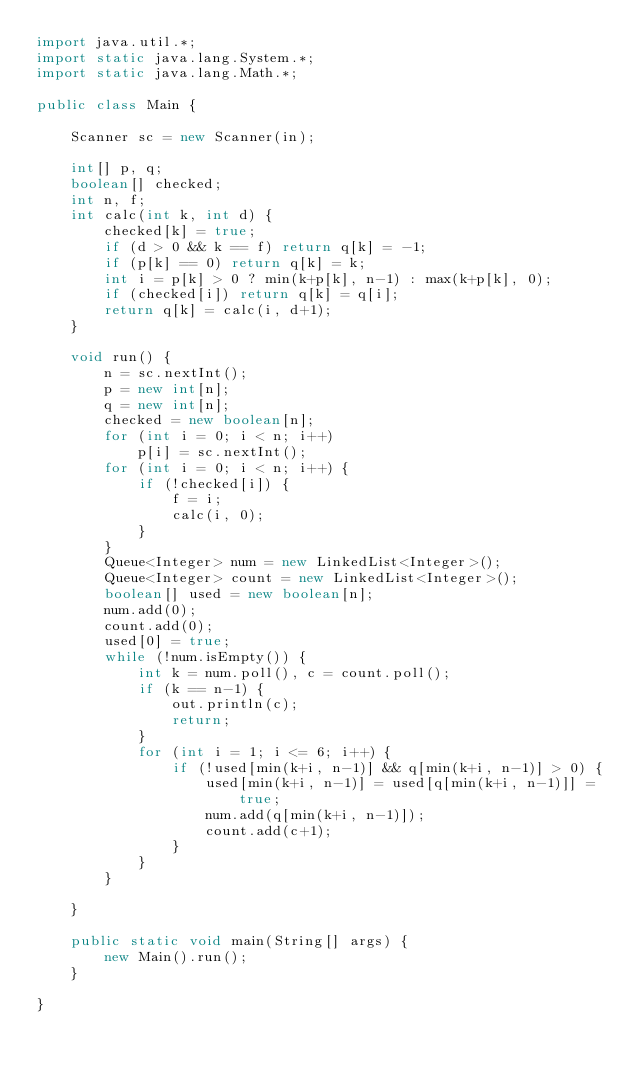Convert code to text. <code><loc_0><loc_0><loc_500><loc_500><_Java_>import java.util.*;
import static java.lang.System.*;
import static java.lang.Math.*;

public class Main {

	Scanner sc = new Scanner(in);
	
	int[] p, q;
	boolean[] checked;
	int n, f;
	int calc(int k, int d) {
		checked[k] = true;
		if (d > 0 && k == f) return q[k] = -1;
		if (p[k] == 0) return q[k] = k;
		int i = p[k] > 0 ? min(k+p[k], n-1) : max(k+p[k], 0);
		if (checked[i]) return q[k] = q[i];
		return q[k] = calc(i, d+1);
	}
	
	void run() {
		n = sc.nextInt();
		p = new int[n];
		q = new int[n];
		checked = new boolean[n];
		for (int i = 0; i < n; i++)
			p[i] = sc.nextInt();
		for (int i = 0; i < n; i++) {
			if (!checked[i]) {
				f = i;
				calc(i, 0);
			}
		}
		Queue<Integer> num = new LinkedList<Integer>();
		Queue<Integer> count = new LinkedList<Integer>();
		boolean[] used = new boolean[n];
		num.add(0);
		count.add(0);
		used[0] = true;
		while (!num.isEmpty()) {
			int k = num.poll(), c = count.poll();
			if (k == n-1) {
				out.println(c);
				return;
			}
			for (int i = 1; i <= 6; i++) {
				if (!used[min(k+i, n-1)] && q[min(k+i, n-1)] > 0) {
					used[min(k+i, n-1)] = used[q[min(k+i, n-1)]] = true;
					num.add(q[min(k+i, n-1)]);
					count.add(c+1);
				}
			}
		}
		
	}
	
	public static void main(String[] args) {
		new Main().run();
	}

}</code> 